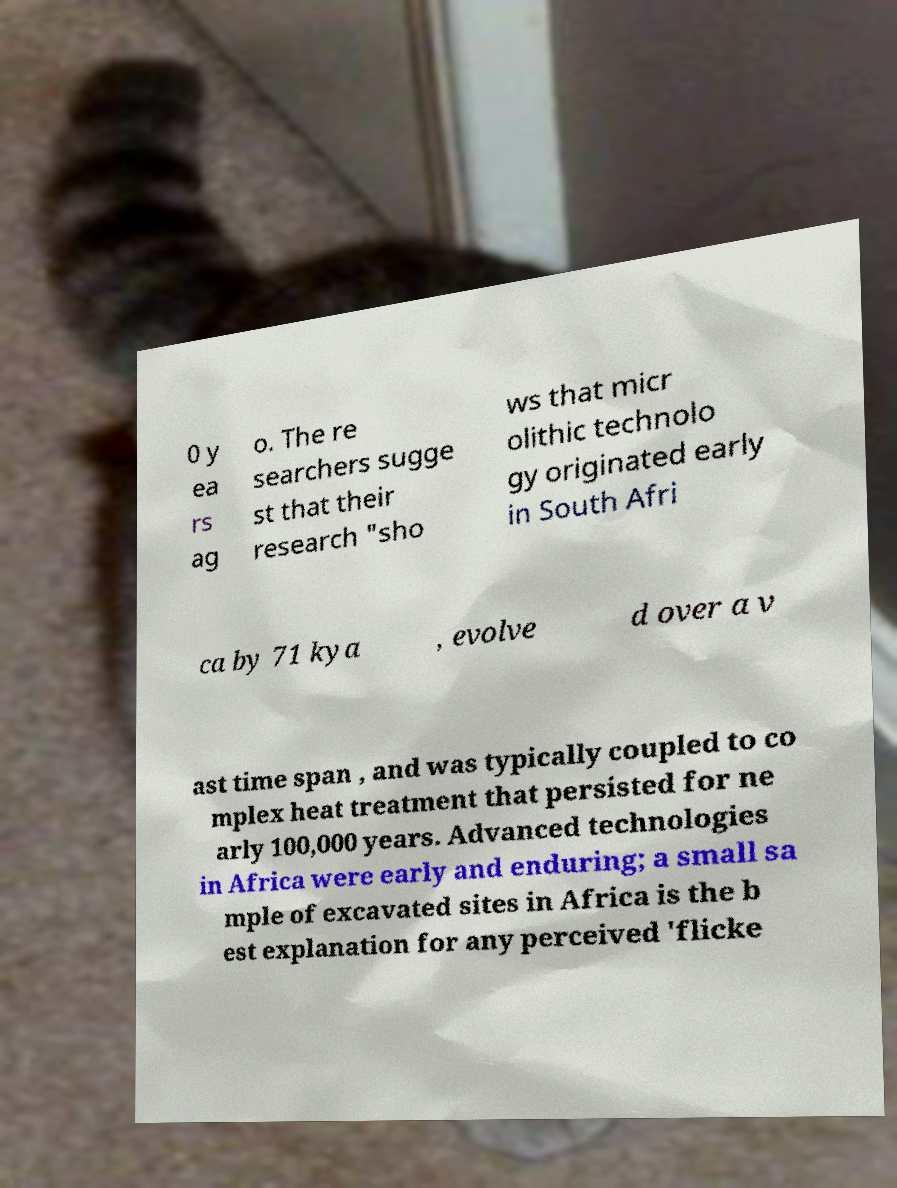Can you accurately transcribe the text from the provided image for me? 0 y ea rs ag o. The re searchers sugge st that their research "sho ws that micr olithic technolo gy originated early in South Afri ca by 71 kya , evolve d over a v ast time span , and was typically coupled to co mplex heat treatment that persisted for ne arly 100,000 years. Advanced technologies in Africa were early and enduring; a small sa mple of excavated sites in Africa is the b est explanation for any perceived 'flicke 